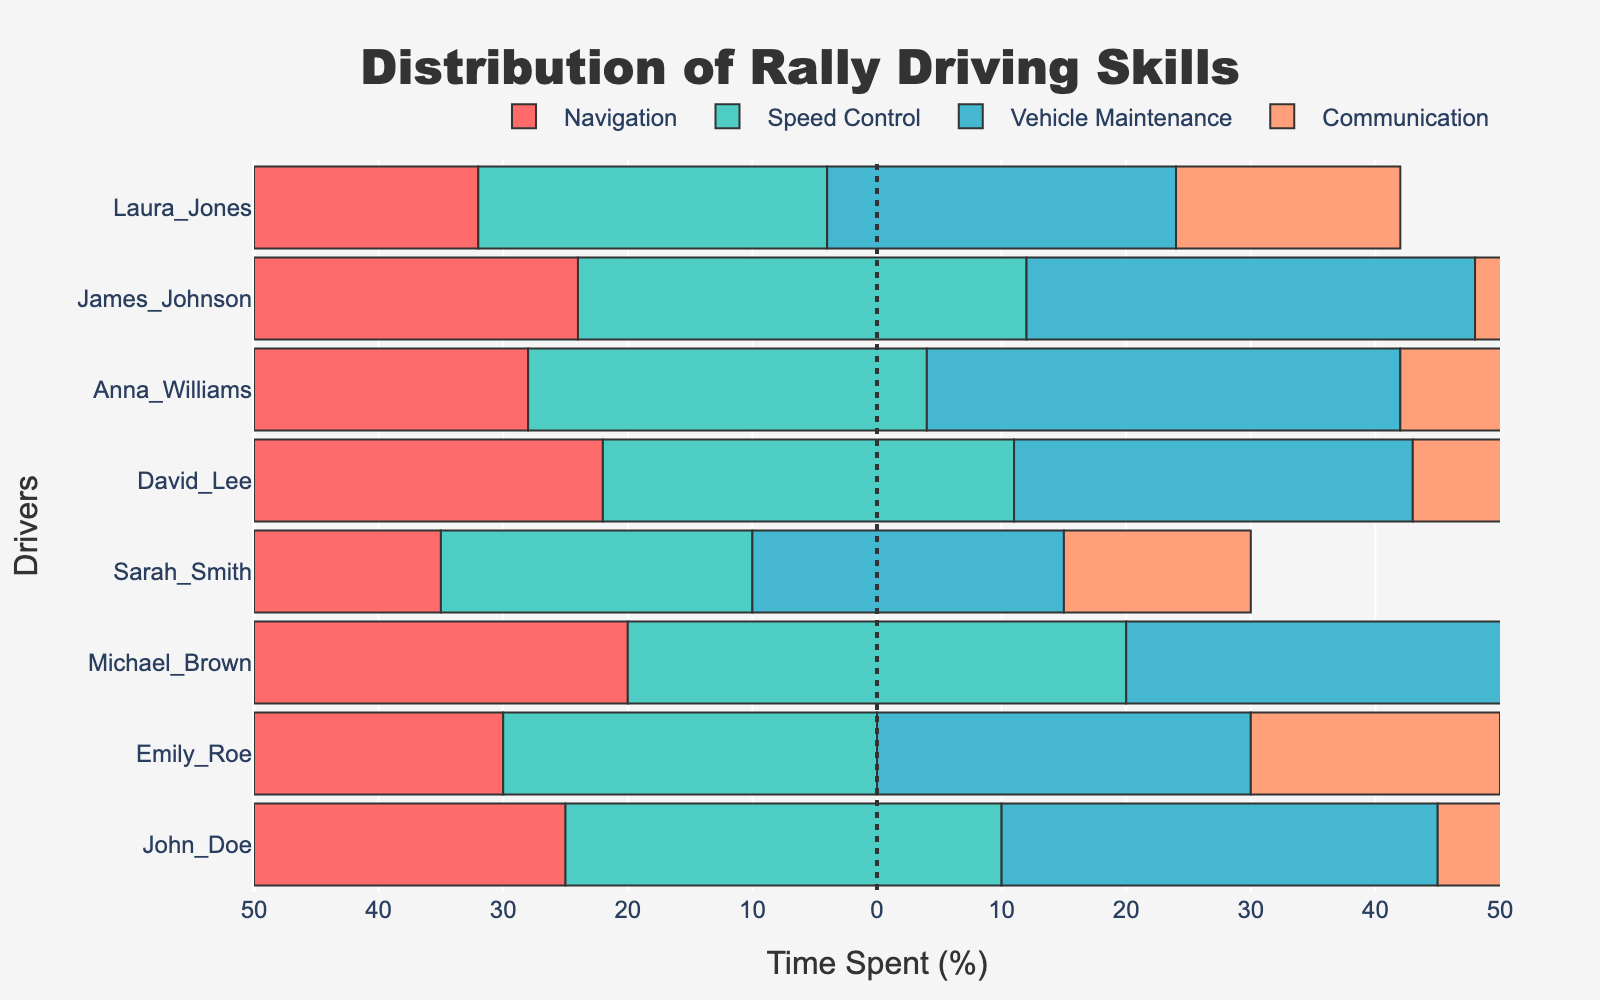What percentage of time does Sarah Smith spend on communication? Sarah Smith's communication bar indicates how much time she allocates to communication in percentage terms. By examining the bar length for the communication category, we can find that Sarah Smith spends 15% of her time on communication.
Answer: 15% Who spends the most time on vehicle maintenance and how much time do they spend? To determine this, inspect the length of the bars for vehicle maintenance. The person with the longest bar for vehicle maintenance is Sarah Smith, spending 25% of her time on it.
Answer: Sarah Smith, 25% Compare the overall time spent on navigation between Laura Jones and Michael Brown. Who spends more time and by how much? Looking at the navigation bars for Laura Jones and Michael Brown, Laura spends 32% of her time on navigation, while Michael spends 20%. Therefore, Laura spends 12% more time on navigation compared to Michael.
Answer: Laura Jones, 12% more What is the average percentage of time spent on speed control across all drivers? First, sum up the time spent on speed control by all drivers (35+30+40+25+33+32+36+28=259). Then, divide by the number of drivers (259/8). The average percentage can be rounded to one decimal point, resulting in 32.4%.
Answer: 32.4% Between John Doe and Emily Roe, who spends a higher percentage of their time on communication and by how much? John Doe spends 25% on communication, while Emily Roe spends 20%. By subtracting these percentages, we find that John spends 5% more time on communication than Emily.
Answer: John Doe, 5% more Which skill does David Lee spend the least amount of time on and what is the percentage? Examining David Lee's bars, note the shortest bar corresponds to navigation, where David spends 22% of his time.
Answer: Navigation, 22% Calculate the difference in the overall rating between Anna Williams and Sarah Smith. By comparing their overall ratings, Anna Williams has a rating of 4.1 and Sarah Smith has 4.5. The difference between these ratings is 4.5 - 4.1 = 0.4.
Answer: 0.4 Which driver has the highest overall rating and what is it? The driver with the highest overall rating is Sarah Smith, with a rating of 4.5.
Answer: Sarah Smith, 4.5 Identify the driver who spends an equal percentage of their time on two different skills and specify the skills and percentage. Emily Roe spends 30% of her time on both navigation and speed control.
Answer: Emily Roe, Navigation and Speed Control, 30% 